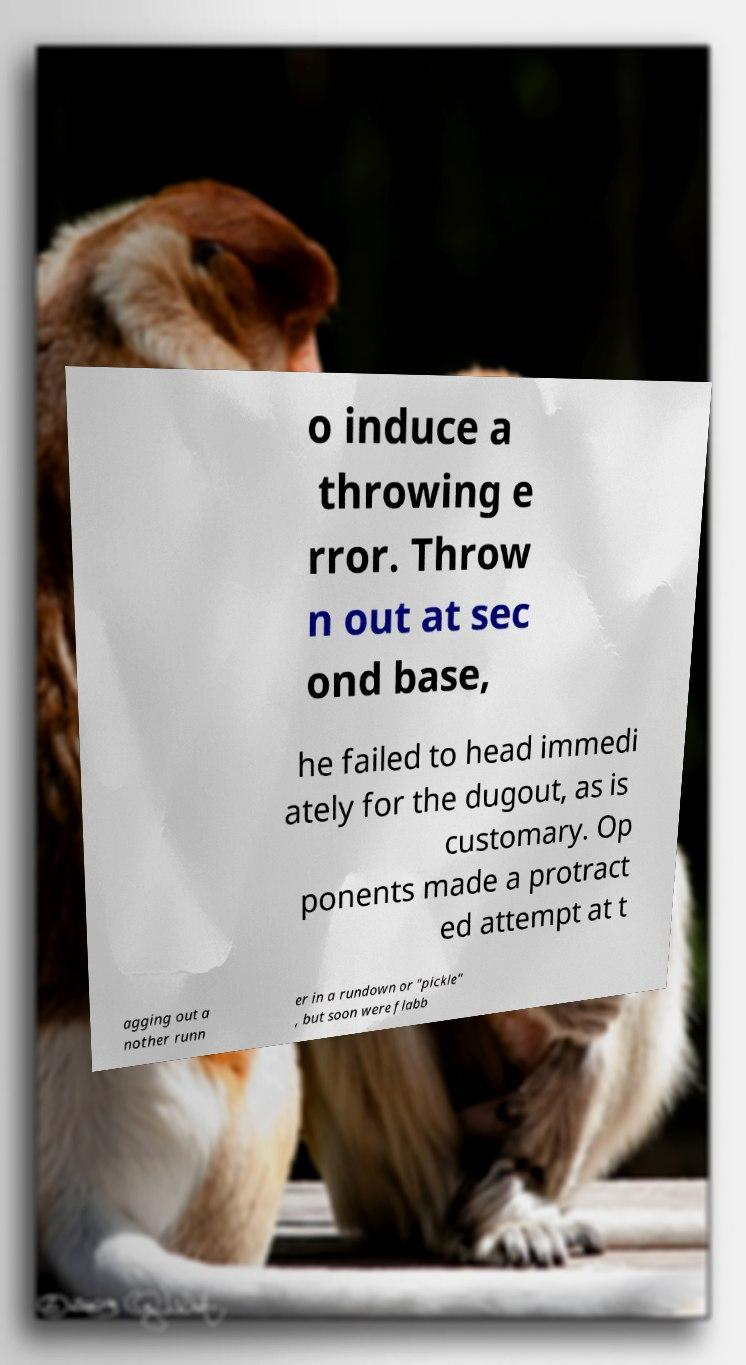Please read and relay the text visible in this image. What does it say? o induce a throwing e rror. Throw n out at sec ond base, he failed to head immedi ately for the dugout, as is customary. Op ponents made a protract ed attempt at t agging out a nother runn er in a rundown or "pickle" , but soon were flabb 